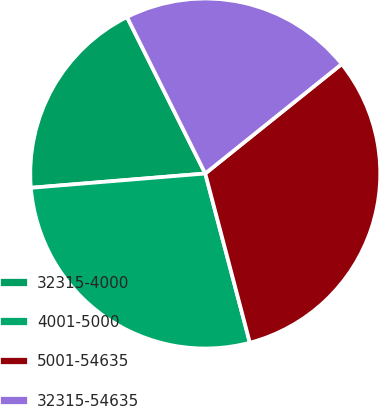Convert chart. <chart><loc_0><loc_0><loc_500><loc_500><pie_chart><fcel>32315-4000<fcel>4001-5000<fcel>5001-54635<fcel>32315-54635<nl><fcel>18.92%<fcel>27.8%<fcel>31.66%<fcel>21.62%<nl></chart> 